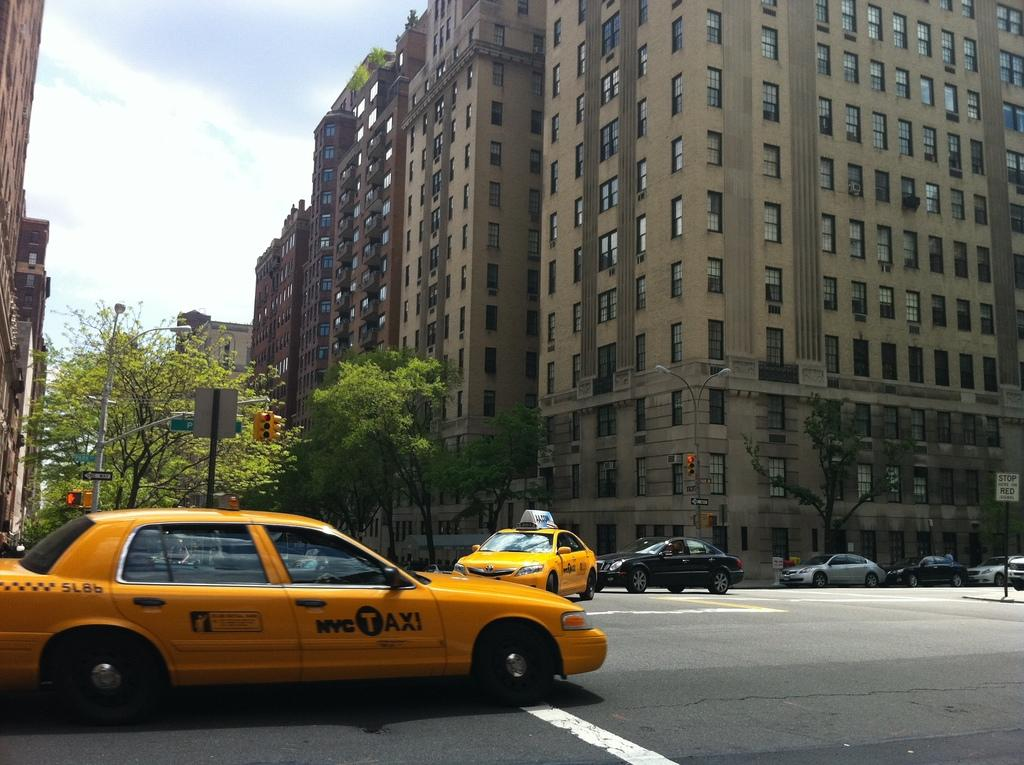Provide a one-sentence caption for the provided image. An NYC taxi is shown at an intersection. 